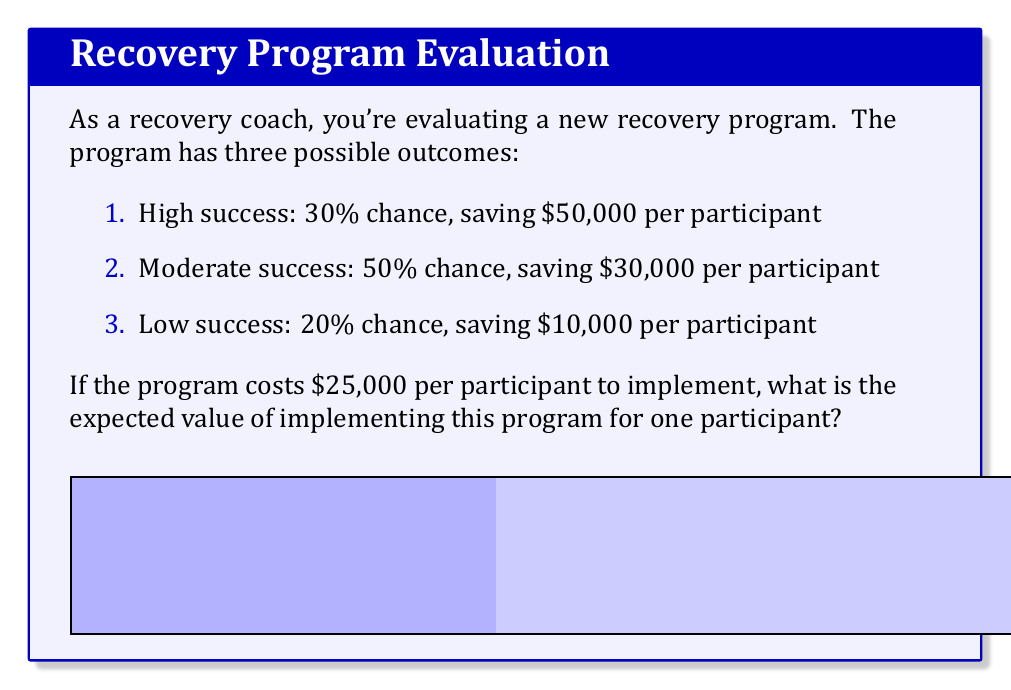Show me your answer to this math problem. To calculate the expected value, we need to:

1. Calculate the net savings for each outcome
2. Multiply each net saving by its probability
3. Sum these weighted values

Step 1: Calculate net savings
- High success: $50,000 - $25,000 = $25,000
- Moderate success: $30,000 - $25,000 = $5,000
- Low success: $10,000 - $25,000 = -$15,000

Step 2: Multiply by probabilities
- High success: $25,000 × 0.30 = $7,500
- Moderate success: $5,000 × 0.50 = $2,500
- Low success: -$15,000 × 0.20 = -$3,000

Step 3: Sum the weighted values

Expected Value = $7,500 + $2,500 + (-$3,000) = $7,000

We can express this mathematically as:

$$E = \sum_{i=1}^{n} p_i(s_i - c)$$

Where:
$E$ is the expected value
$p_i$ is the probability of each outcome
$s_i$ is the savings for each outcome
$c$ is the cost of implementation

$$E = 0.30(50000 - 25000) + 0.50(30000 - 25000) + 0.20(10000 - 25000) = 7000$$
Answer: $7,000 